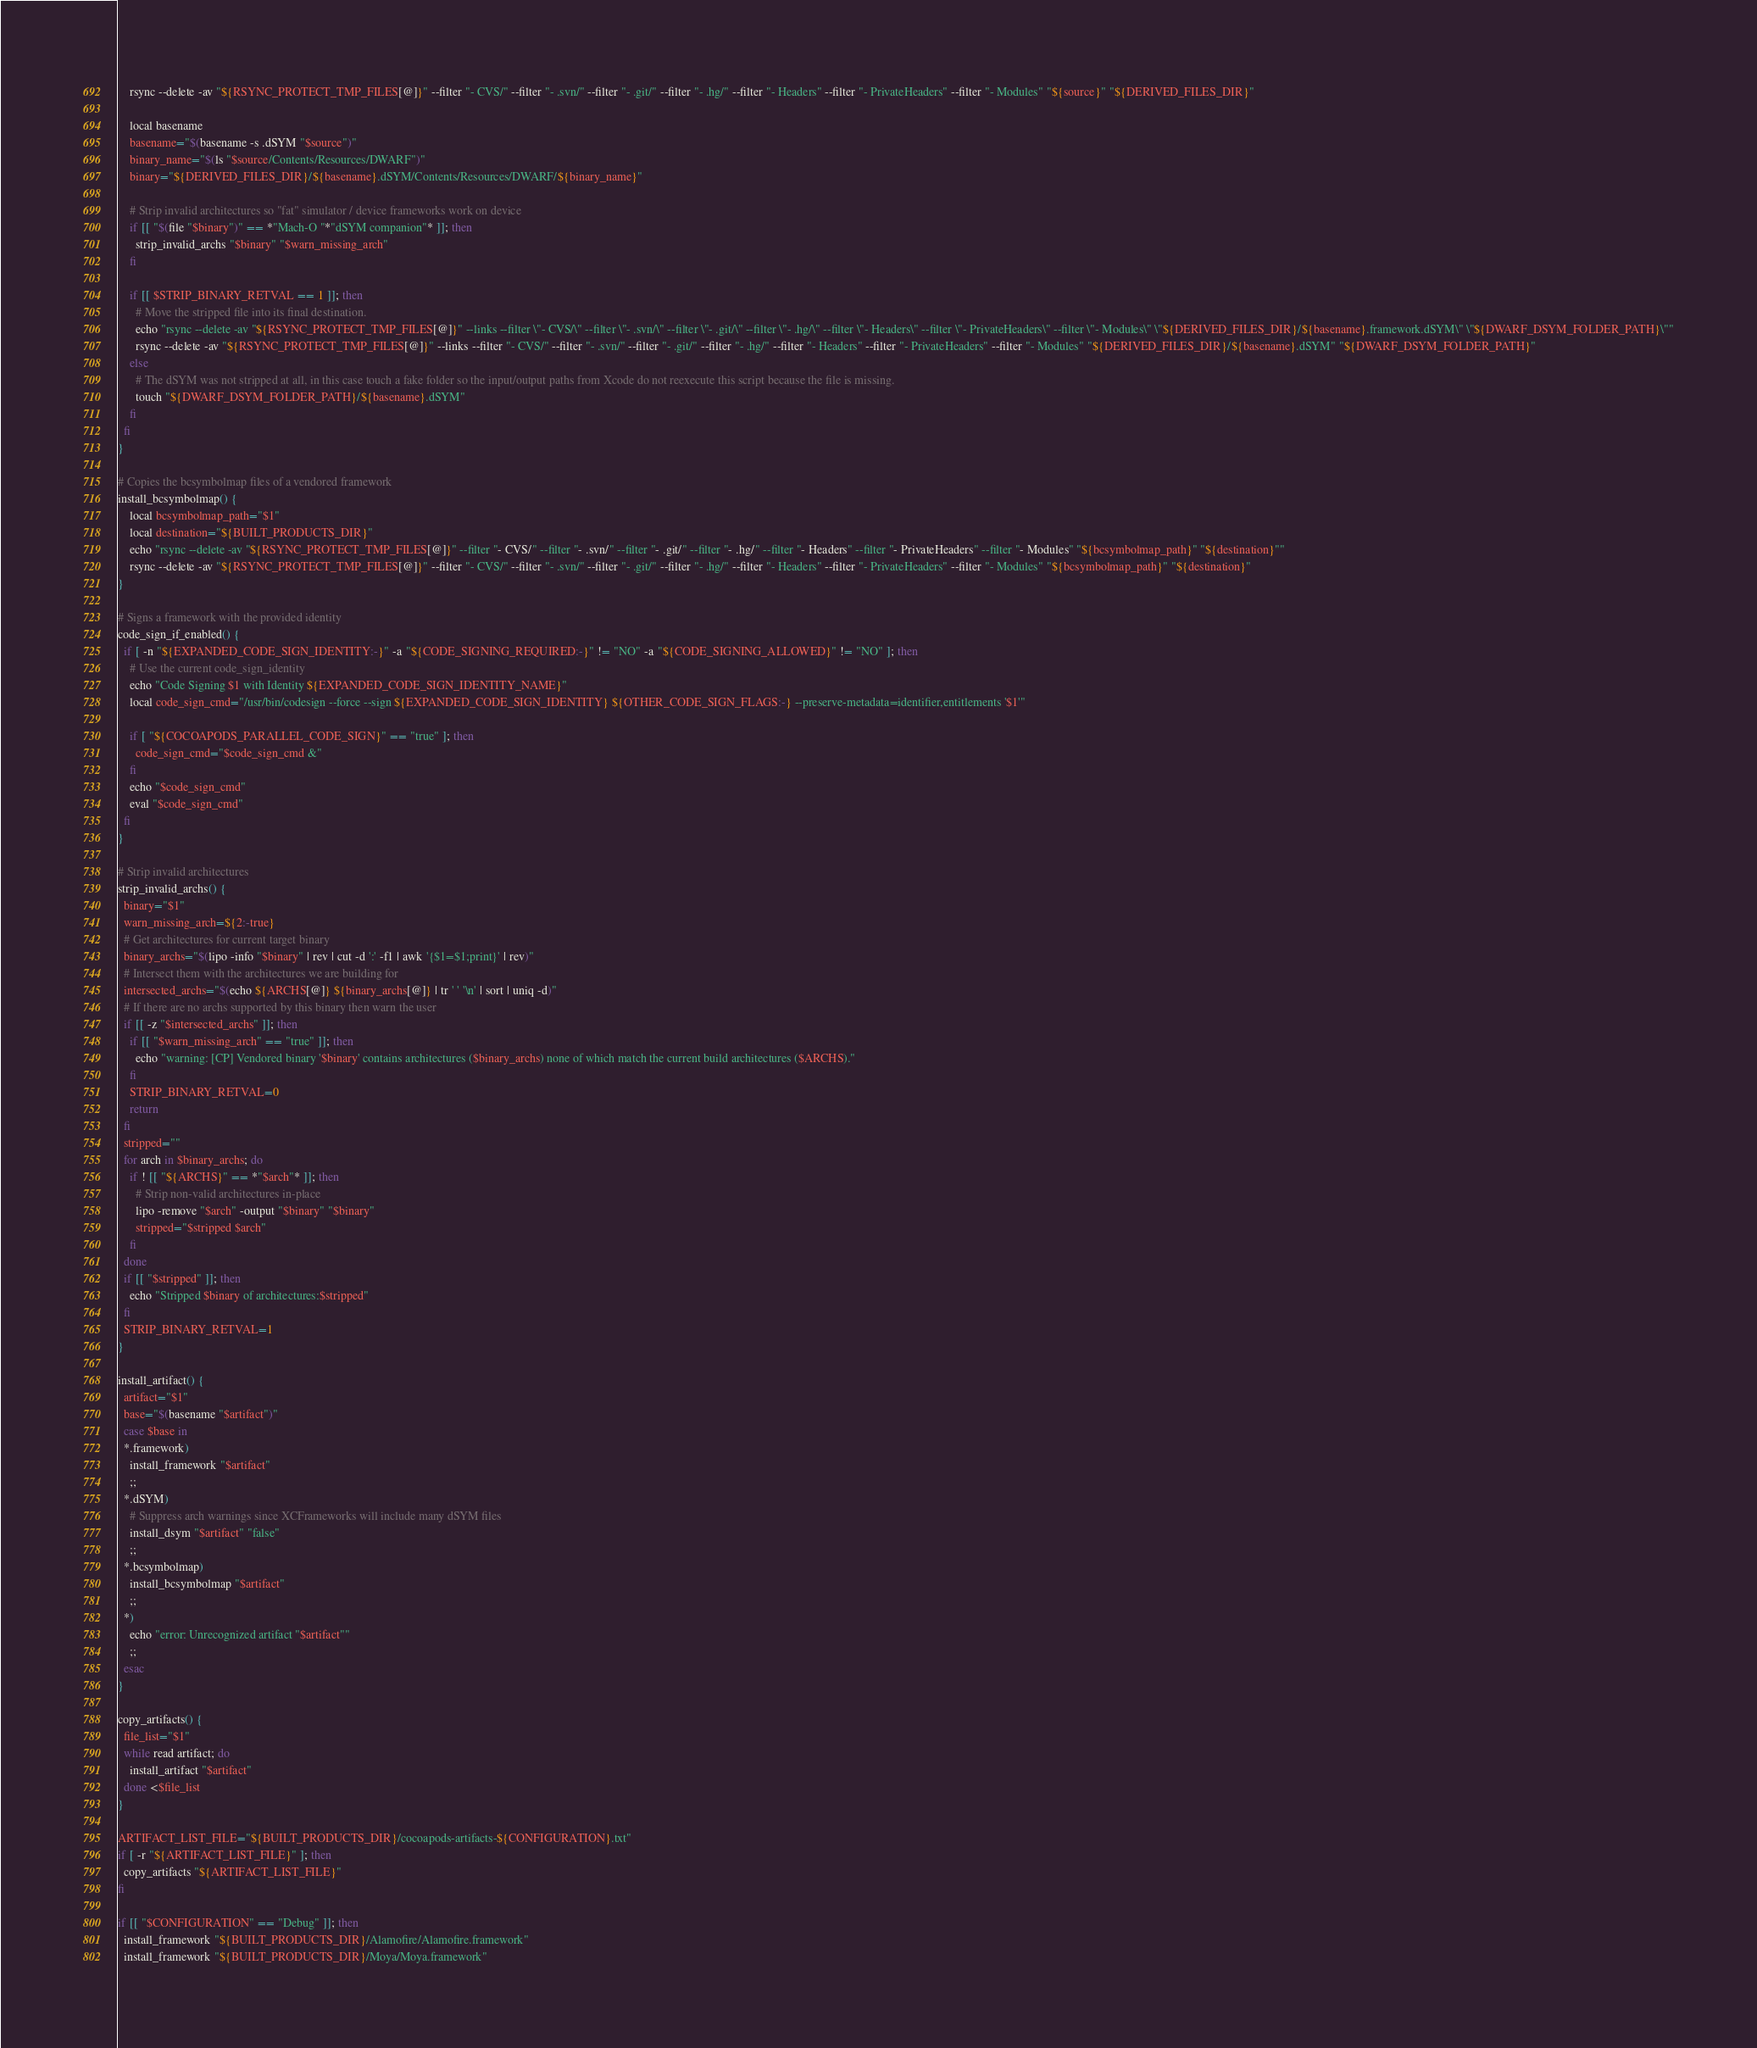<code> <loc_0><loc_0><loc_500><loc_500><_Bash_>    rsync --delete -av "${RSYNC_PROTECT_TMP_FILES[@]}" --filter "- CVS/" --filter "- .svn/" --filter "- .git/" --filter "- .hg/" --filter "- Headers" --filter "- PrivateHeaders" --filter "- Modules" "${source}" "${DERIVED_FILES_DIR}"

    local basename
    basename="$(basename -s .dSYM "$source")"
    binary_name="$(ls "$source/Contents/Resources/DWARF")"
    binary="${DERIVED_FILES_DIR}/${basename}.dSYM/Contents/Resources/DWARF/${binary_name}"

    # Strip invalid architectures so "fat" simulator / device frameworks work on device
    if [[ "$(file "$binary")" == *"Mach-O "*"dSYM companion"* ]]; then
      strip_invalid_archs "$binary" "$warn_missing_arch"
    fi

    if [[ $STRIP_BINARY_RETVAL == 1 ]]; then
      # Move the stripped file into its final destination.
      echo "rsync --delete -av "${RSYNC_PROTECT_TMP_FILES[@]}" --links --filter \"- CVS/\" --filter \"- .svn/\" --filter \"- .git/\" --filter \"- .hg/\" --filter \"- Headers\" --filter \"- PrivateHeaders\" --filter \"- Modules\" \"${DERIVED_FILES_DIR}/${basename}.framework.dSYM\" \"${DWARF_DSYM_FOLDER_PATH}\""
      rsync --delete -av "${RSYNC_PROTECT_TMP_FILES[@]}" --links --filter "- CVS/" --filter "- .svn/" --filter "- .git/" --filter "- .hg/" --filter "- Headers" --filter "- PrivateHeaders" --filter "- Modules" "${DERIVED_FILES_DIR}/${basename}.dSYM" "${DWARF_DSYM_FOLDER_PATH}"
    else
      # The dSYM was not stripped at all, in this case touch a fake folder so the input/output paths from Xcode do not reexecute this script because the file is missing.
      touch "${DWARF_DSYM_FOLDER_PATH}/${basename}.dSYM"
    fi
  fi
}

# Copies the bcsymbolmap files of a vendored framework
install_bcsymbolmap() {
    local bcsymbolmap_path="$1"
    local destination="${BUILT_PRODUCTS_DIR}"
    echo "rsync --delete -av "${RSYNC_PROTECT_TMP_FILES[@]}" --filter "- CVS/" --filter "- .svn/" --filter "- .git/" --filter "- .hg/" --filter "- Headers" --filter "- PrivateHeaders" --filter "- Modules" "${bcsymbolmap_path}" "${destination}""
    rsync --delete -av "${RSYNC_PROTECT_TMP_FILES[@]}" --filter "- CVS/" --filter "- .svn/" --filter "- .git/" --filter "- .hg/" --filter "- Headers" --filter "- PrivateHeaders" --filter "- Modules" "${bcsymbolmap_path}" "${destination}"
}

# Signs a framework with the provided identity
code_sign_if_enabled() {
  if [ -n "${EXPANDED_CODE_SIGN_IDENTITY:-}" -a "${CODE_SIGNING_REQUIRED:-}" != "NO" -a "${CODE_SIGNING_ALLOWED}" != "NO" ]; then
    # Use the current code_sign_identity
    echo "Code Signing $1 with Identity ${EXPANDED_CODE_SIGN_IDENTITY_NAME}"
    local code_sign_cmd="/usr/bin/codesign --force --sign ${EXPANDED_CODE_SIGN_IDENTITY} ${OTHER_CODE_SIGN_FLAGS:-} --preserve-metadata=identifier,entitlements '$1'"

    if [ "${COCOAPODS_PARALLEL_CODE_SIGN}" == "true" ]; then
      code_sign_cmd="$code_sign_cmd &"
    fi
    echo "$code_sign_cmd"
    eval "$code_sign_cmd"
  fi
}

# Strip invalid architectures
strip_invalid_archs() {
  binary="$1"
  warn_missing_arch=${2:-true}
  # Get architectures for current target binary
  binary_archs="$(lipo -info "$binary" | rev | cut -d ':' -f1 | awk '{$1=$1;print}' | rev)"
  # Intersect them with the architectures we are building for
  intersected_archs="$(echo ${ARCHS[@]} ${binary_archs[@]} | tr ' ' '\n' | sort | uniq -d)"
  # If there are no archs supported by this binary then warn the user
  if [[ -z "$intersected_archs" ]]; then
    if [[ "$warn_missing_arch" == "true" ]]; then
      echo "warning: [CP] Vendored binary '$binary' contains architectures ($binary_archs) none of which match the current build architectures ($ARCHS)."
    fi
    STRIP_BINARY_RETVAL=0
    return
  fi
  stripped=""
  for arch in $binary_archs; do
    if ! [[ "${ARCHS}" == *"$arch"* ]]; then
      # Strip non-valid architectures in-place
      lipo -remove "$arch" -output "$binary" "$binary"
      stripped="$stripped $arch"
    fi
  done
  if [[ "$stripped" ]]; then
    echo "Stripped $binary of architectures:$stripped"
  fi
  STRIP_BINARY_RETVAL=1
}

install_artifact() {
  artifact="$1"
  base="$(basename "$artifact")"
  case $base in
  *.framework)
    install_framework "$artifact"
    ;;
  *.dSYM)
    # Suppress arch warnings since XCFrameworks will include many dSYM files
    install_dsym "$artifact" "false"
    ;;
  *.bcsymbolmap)
    install_bcsymbolmap "$artifact"
    ;;
  *)
    echo "error: Unrecognized artifact "$artifact""
    ;;
  esac
}

copy_artifacts() {
  file_list="$1"
  while read artifact; do
    install_artifact "$artifact"
  done <$file_list
}

ARTIFACT_LIST_FILE="${BUILT_PRODUCTS_DIR}/cocoapods-artifacts-${CONFIGURATION}.txt"
if [ -r "${ARTIFACT_LIST_FILE}" ]; then
  copy_artifacts "${ARTIFACT_LIST_FILE}"
fi

if [[ "$CONFIGURATION" == "Debug" ]]; then
  install_framework "${BUILT_PRODUCTS_DIR}/Alamofire/Alamofire.framework"
  install_framework "${BUILT_PRODUCTS_DIR}/Moya/Moya.framework"</code> 